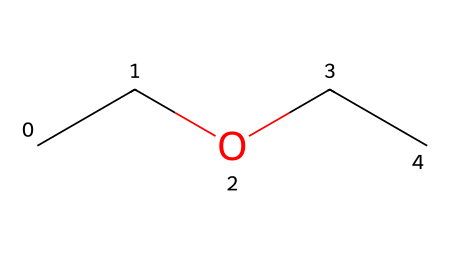What is the name of this chemical? The SMILES representation "CCOCC" corresponds to diethyl ether, which is a common ether used in various applications including early anesthesia.
Answer: diethyl ether How many carbon atoms are in the structure? The structure "CCOCC" contains four carbon atoms (two in each ethyl group).
Answer: four How many oxygen atoms are present? The structure shows one oxygen atom connecting the two ethyl groups, indicated by "O" in the SMILES notation.
Answer: one What type of functional group does diethyl ether contain? The presence of an oxygen atom connected to two carbon chains indicates that it contains an ether functional group, characteristic of ethers.
Answer: ether What is the molecular formula of diethyl ether? By analyzing the structure, there are four carbon atoms and ten hydrogen atoms, resulting in the molecular formula C4H10O.
Answer: C4H10O Is diethyl ether a polar or non-polar molecule? The molecule has an oxygen atom, which provides polar characteristics, but the two ethyl groups are non-polar, resulting in an overall non-polar molecule.
Answer: non-polar How does the structure influence its use in anesthesia? The symmetrical and relatively simple structure allows for rapid volatilization and absorption in the body, making it effective for use in anesthesia.
Answer: rapid volatilization 